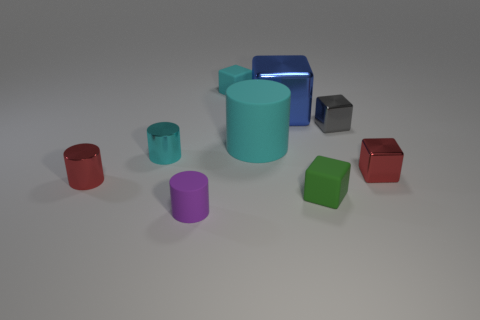The block that is the same color as the large matte thing is what size?
Make the answer very short. Small. Are there any tiny matte objects of the same color as the large matte object?
Keep it short and to the point. Yes. What shape is the small rubber thing that is the same color as the large matte object?
Give a very brief answer. Cube. What number of things are matte blocks in front of the cyan metal object or tiny brown rubber cylinders?
Make the answer very short. 1. What number of brown metallic cylinders are there?
Make the answer very short. 0. What shape is the gray object that is made of the same material as the red block?
Your answer should be very brief. Cube. What is the size of the rubber cylinder behind the object in front of the small green cube?
Give a very brief answer. Large. How many objects are either tiny metallic objects in front of the big cyan matte thing or things that are behind the big cyan cylinder?
Offer a terse response. 6. Is the number of green matte balls less than the number of matte things?
Your answer should be compact. Yes. How many things are yellow matte balls or big cyan cylinders?
Ensure brevity in your answer.  1. 